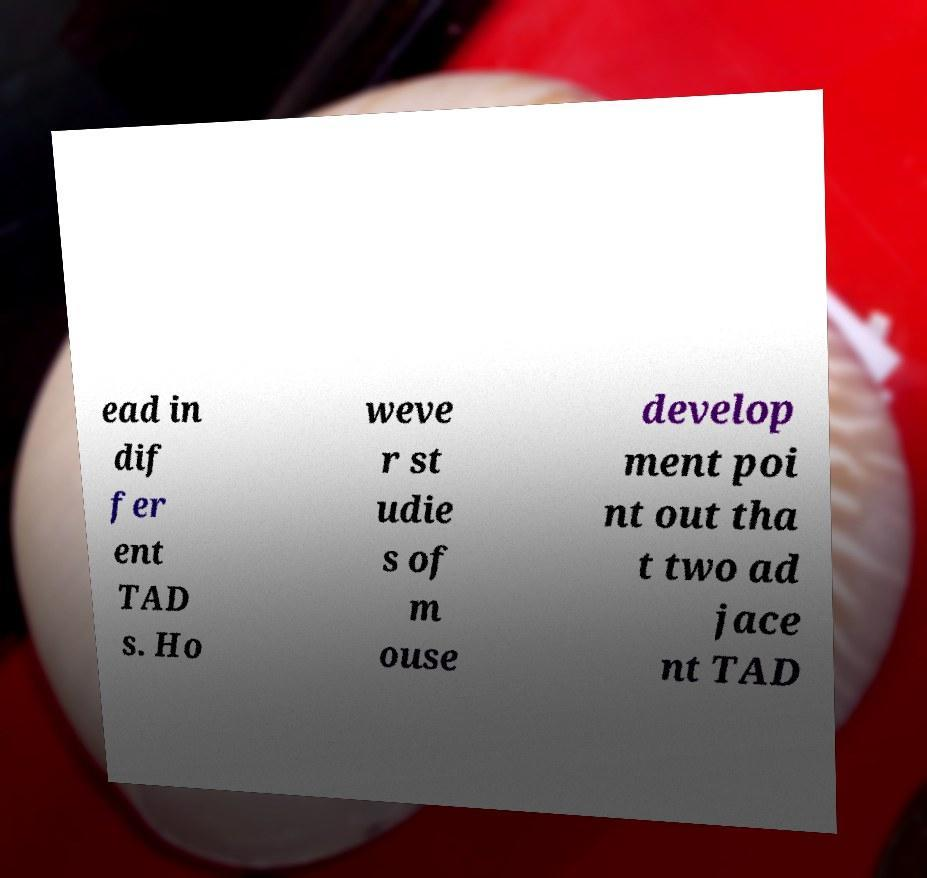Can you read and provide the text displayed in the image?This photo seems to have some interesting text. Can you extract and type it out for me? ead in dif fer ent TAD s. Ho weve r st udie s of m ouse develop ment poi nt out tha t two ad jace nt TAD 